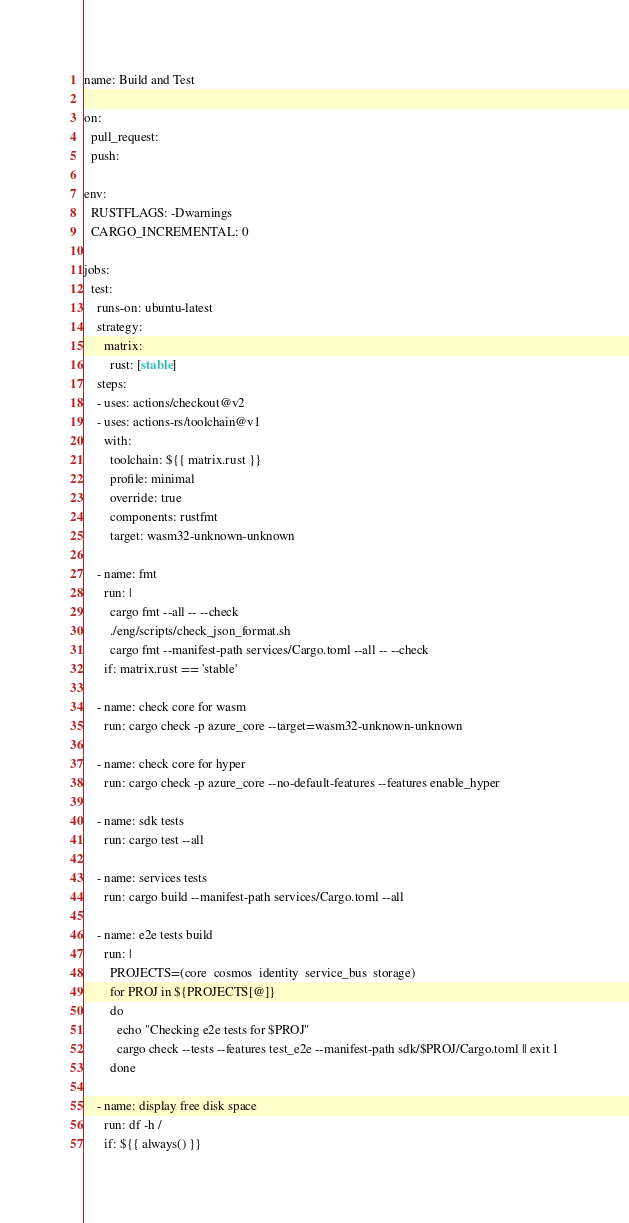<code> <loc_0><loc_0><loc_500><loc_500><_YAML_>name: Build and Test

on:
  pull_request:
  push:

env:
  RUSTFLAGS: -Dwarnings
  CARGO_INCREMENTAL: 0

jobs:
  test:
    runs-on: ubuntu-latest
    strategy:
      matrix:
        rust: [stable]
    steps:
    - uses: actions/checkout@v2
    - uses: actions-rs/toolchain@v1
      with:
        toolchain: ${{ matrix.rust }}
        profile: minimal
        override: true
        components: rustfmt
        target: wasm32-unknown-unknown

    - name: fmt
      run: |
        cargo fmt --all -- --check
        ./eng/scripts/check_json_format.sh
        cargo fmt --manifest-path services/Cargo.toml --all -- --check
      if: matrix.rust == 'stable'

    - name: check core for wasm
      run: cargo check -p azure_core --target=wasm32-unknown-unknown

    - name: check core for hyper
      run: cargo check -p azure_core --no-default-features --features enable_hyper

    - name: sdk tests
      run: cargo test --all

    - name: services tests
      run: cargo build --manifest-path services/Cargo.toml --all

    - name: e2e tests build
      run: |
        PROJECTS=(core  cosmos  identity  service_bus  storage)
        for PROJ in ${PROJECTS[@]}
        do
          echo "Checking e2e tests for $PROJ"
          cargo check --tests --features test_e2e --manifest-path sdk/$PROJ/Cargo.toml || exit 1
        done

    - name: display free disk space
      run: df -h /
      if: ${{ always() }}
</code> 